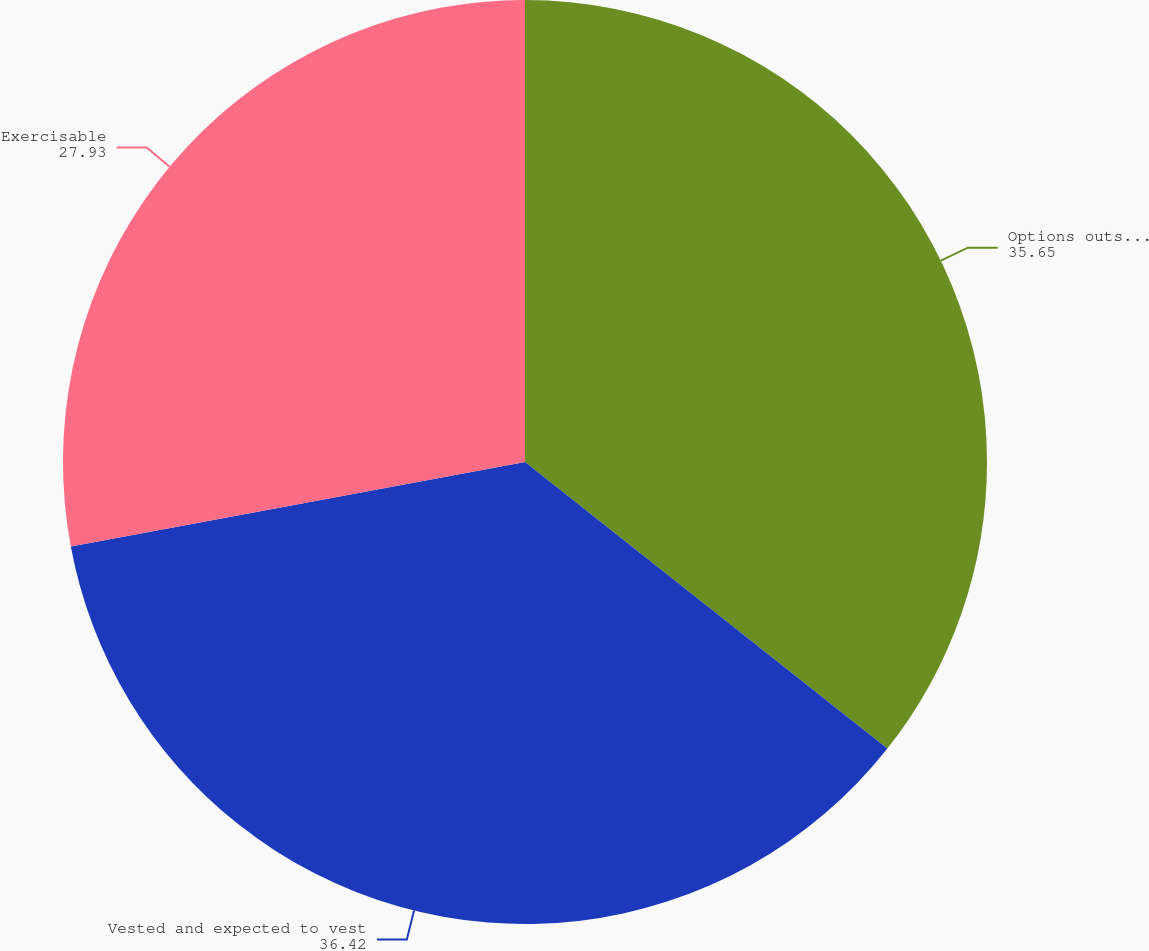<chart> <loc_0><loc_0><loc_500><loc_500><pie_chart><fcel>Options outstanding at<fcel>Vested and expected to vest<fcel>Exercisable<nl><fcel>35.65%<fcel>36.42%<fcel>27.93%<nl></chart> 